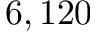<formula> <loc_0><loc_0><loc_500><loc_500>6 , 1 2 0</formula> 